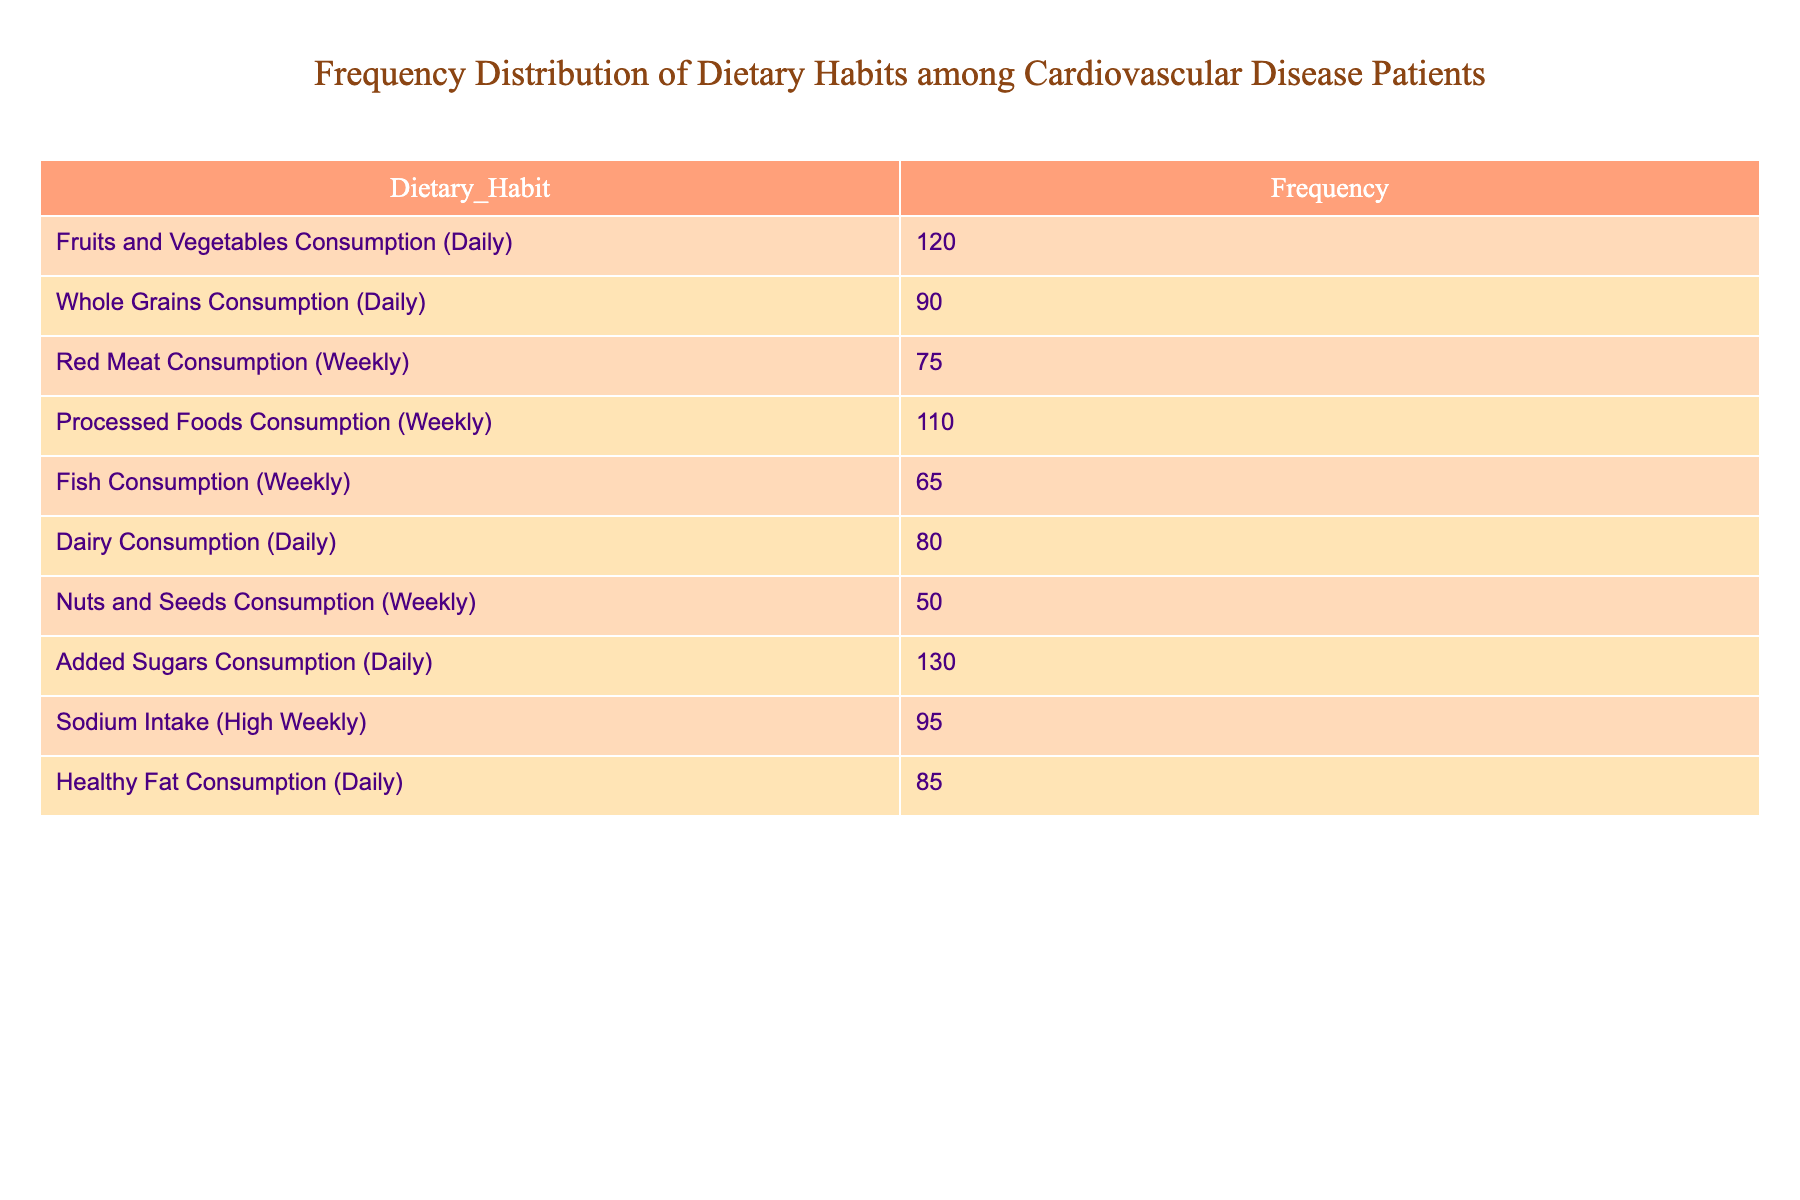What is the frequency of daily Fruits and Vegetables consumption? The table shows the frequency for various dietary habits, and specifically lists "Fruits and Vegetables Consumption (Daily)" with a frequency of 120.
Answer: 120 How many patients consume Processed Foods weekly? Referring to the table, "Processed Foods Consumption (Weekly)" has a frequency of 110 patients.
Answer: 110 What is the total frequency of patients consuming added sugars daily and those consuming healthy fats daily? To find the total, we add the frequencies for "Added Sugars Consumption (Daily)" which is 130 and "Healthy Fat Consumption (Daily)" which is 85. So, 130 + 85 equals 215.
Answer: 215 Which dietary habit has the lowest frequency among the listed habits? Scanning through the frequencies, "Nuts and Seeds Consumption (Weekly)" has the lowest frequency at 50.
Answer: 50 Is the frequency of Fish Consumption weekly greater than that of Dairy Consumption daily? The table indicates that "Fish Consumption (Weekly)" has a frequency of 65, whereas "Dairy Consumption (Daily)" has a frequency of 80. Since 65 is less than 80, the answer is no.
Answer: No What is the average frequency of all dietary habits listed in the table? We first sum up all the frequencies: 120 + 90 + 75 + 110 + 65 + 80 + 50 + 130 + 95 + 85 equals 1000. Then, we divide by the number of dietary habits, which is 10, resulting in an average of 1000/10 = 100.
Answer: 100 How many patients consume high sodium intake weekly? The table presents "Sodium Intake (High Weekly)" with a frequency of 95 patients.
Answer: 95 Which dietary habit has a higher frequency: Whole Grains Consumption daily or Nuts and Seeds Consumption weekly? The table indicates "Whole Grains Consumption (Daily)" has a frequency of 90, while "Nuts and Seeds Consumption (Weekly)" has a frequency of 50. Since 90 is greater than 50, the answer is Whole Grains Consumption.
Answer: Whole Grains Consumption (Daily) 